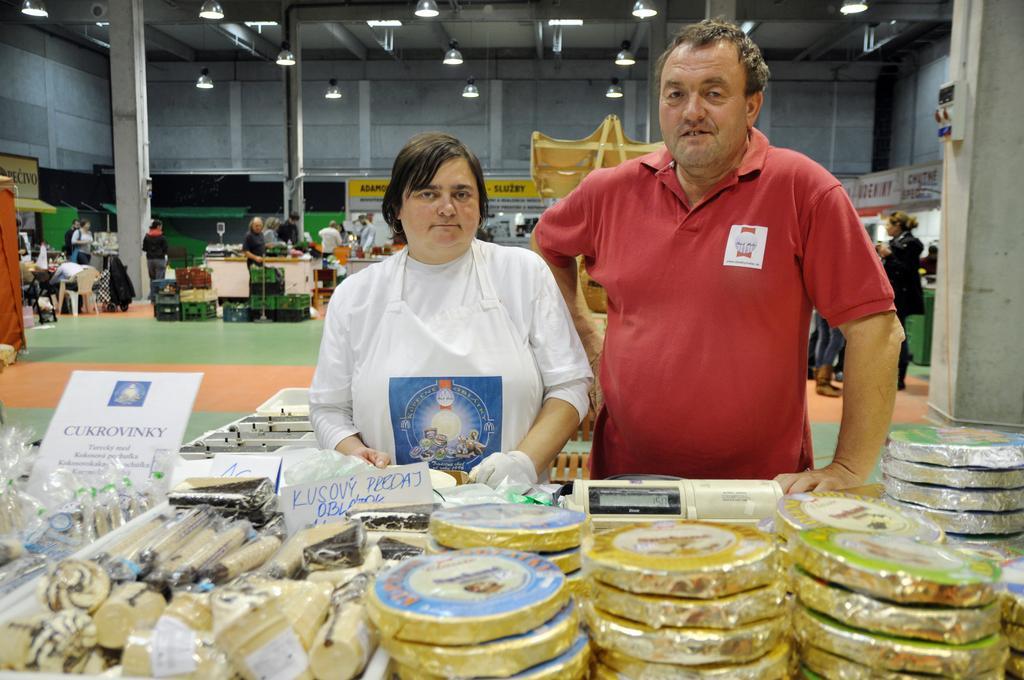Please provide a concise description of this image. In this image, we can see two people are watching and standing. At the bottom, we can see few things, machine, boards and some objects. Background we can see stalls, few people, baskets, chairs, tables and hoardings. Here we can see the floor. Top of the image, we can see walls, pillars, lights and rods. 